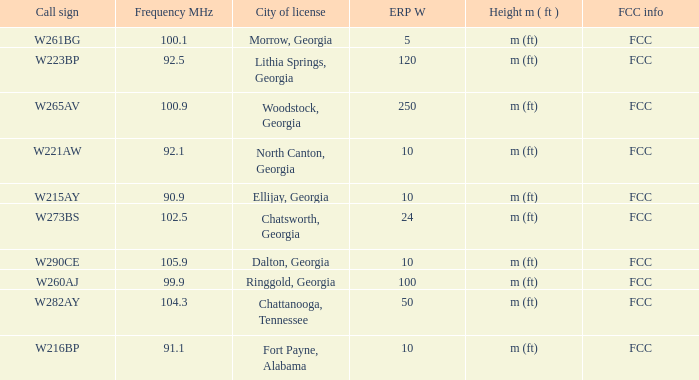In which licensed city is the frequency mhz less than 100.9 and the erp w greater than 100? Lithia Springs, Georgia. 